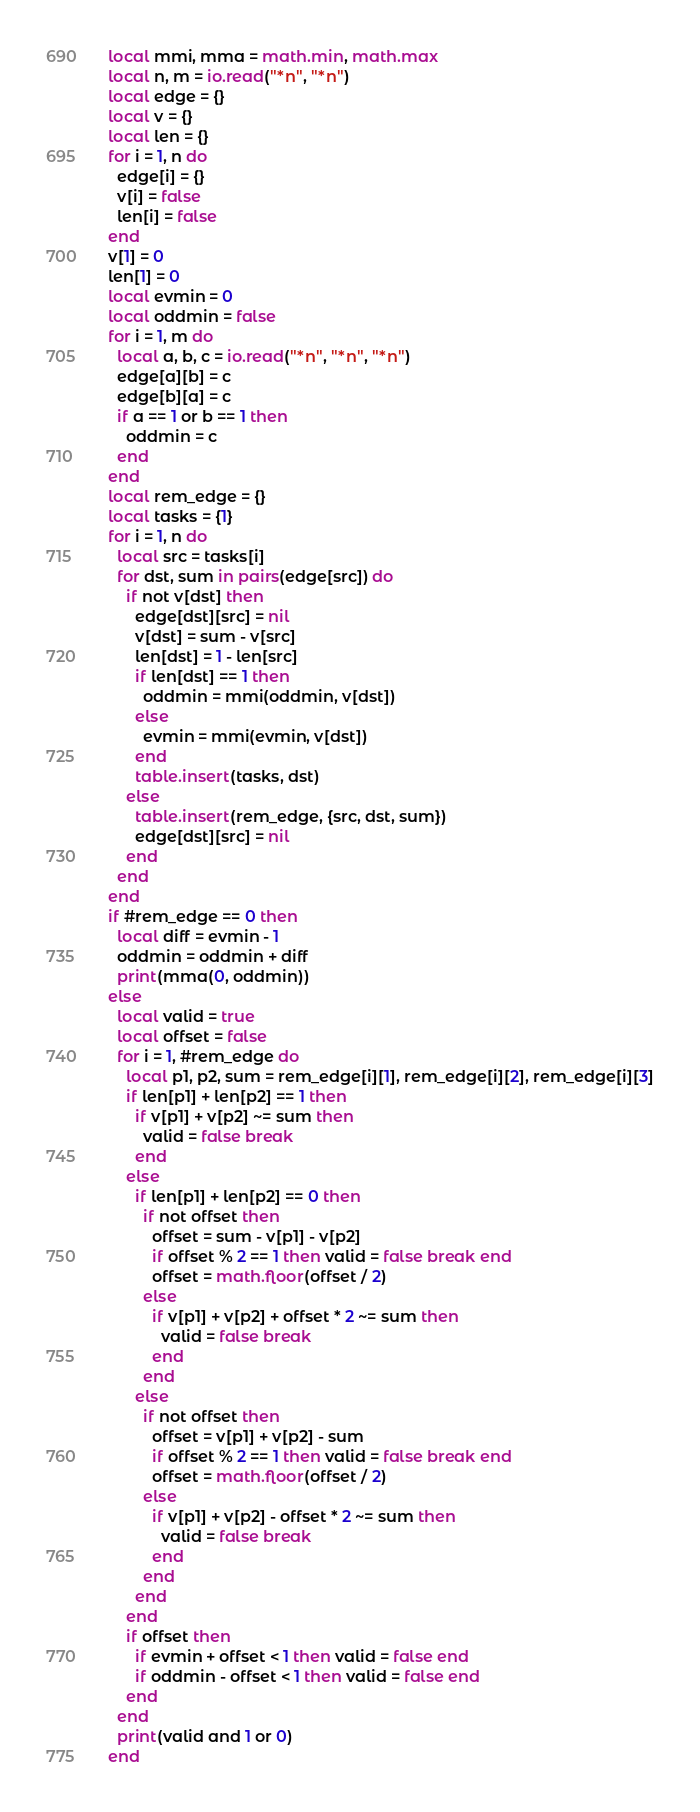Convert code to text. <code><loc_0><loc_0><loc_500><loc_500><_Lua_>local mmi, mma = math.min, math.max
local n, m = io.read("*n", "*n")
local edge = {}
local v = {}
local len = {}
for i = 1, n do
  edge[i] = {}
  v[i] = false
  len[i] = false
end
v[1] = 0
len[1] = 0
local evmin = 0
local oddmin = false
for i = 1, m do
  local a, b, c = io.read("*n", "*n", "*n")
  edge[a][b] = c
  edge[b][a] = c
  if a == 1 or b == 1 then
    oddmin = c
  end
end
local rem_edge = {}
local tasks = {1}
for i = 1, n do
  local src = tasks[i]
  for dst, sum in pairs(edge[src]) do
    if not v[dst] then
      edge[dst][src] = nil
      v[dst] = sum - v[src]
      len[dst] = 1 - len[src]
      if len[dst] == 1 then
        oddmin = mmi(oddmin, v[dst])
      else
        evmin = mmi(evmin, v[dst])
      end
      table.insert(tasks, dst)
    else
      table.insert(rem_edge, {src, dst, sum})
      edge[dst][src] = nil
    end
  end
end
if #rem_edge == 0 then
  local diff = evmin - 1
  oddmin = oddmin + diff
  print(mma(0, oddmin))
else
  local valid = true
  local offset = false
  for i = 1, #rem_edge do
    local p1, p2, sum = rem_edge[i][1], rem_edge[i][2], rem_edge[i][3]
    if len[p1] + len[p2] == 1 then
      if v[p1] + v[p2] ~= sum then
        valid = false break
      end
    else
      if len[p1] + len[p2] == 0 then
        if not offset then
          offset = sum - v[p1] - v[p2]
          if offset % 2 == 1 then valid = false break end
          offset = math.floor(offset / 2)
        else
          if v[p1] + v[p2] + offset * 2 ~= sum then
            valid = false break
          end
        end
      else
        if not offset then
          offset = v[p1] + v[p2] - sum
          if offset % 2 == 1 then valid = false break end
          offset = math.floor(offset / 2)
        else
          if v[p1] + v[p2] - offset * 2 ~= sum then
            valid = false break
          end
        end
      end
    end
    if offset then
      if evmin + offset < 1 then valid = false end
      if oddmin - offset < 1 then valid = false end
    end
  end
  print(valid and 1 or 0)
end
</code> 